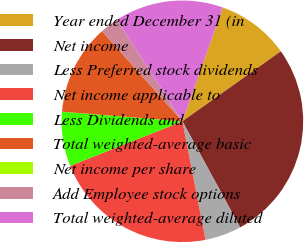Convert chart. <chart><loc_0><loc_0><loc_500><loc_500><pie_chart><fcel>Year ended December 31 (in<fcel>Net income<fcel>Less Preferred stock dividends<fcel>Net income applicable to<fcel>Less Dividends and<fcel>Total weighted-average basic<fcel>Net income per share<fcel>Add Employee stock options<fcel>Total weighted-average diluted<nl><fcel>9.72%<fcel>26.91%<fcel>4.86%<fcel>22.05%<fcel>7.29%<fcel>12.15%<fcel>0.01%<fcel>2.43%<fcel>14.58%<nl></chart> 